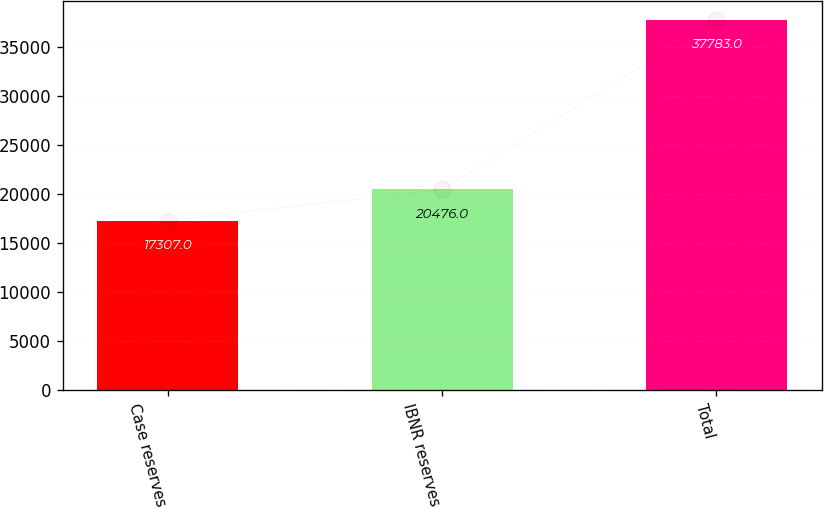Convert chart. <chart><loc_0><loc_0><loc_500><loc_500><bar_chart><fcel>Case reserves<fcel>IBNR reserves<fcel>Total<nl><fcel>17307<fcel>20476<fcel>37783<nl></chart> 